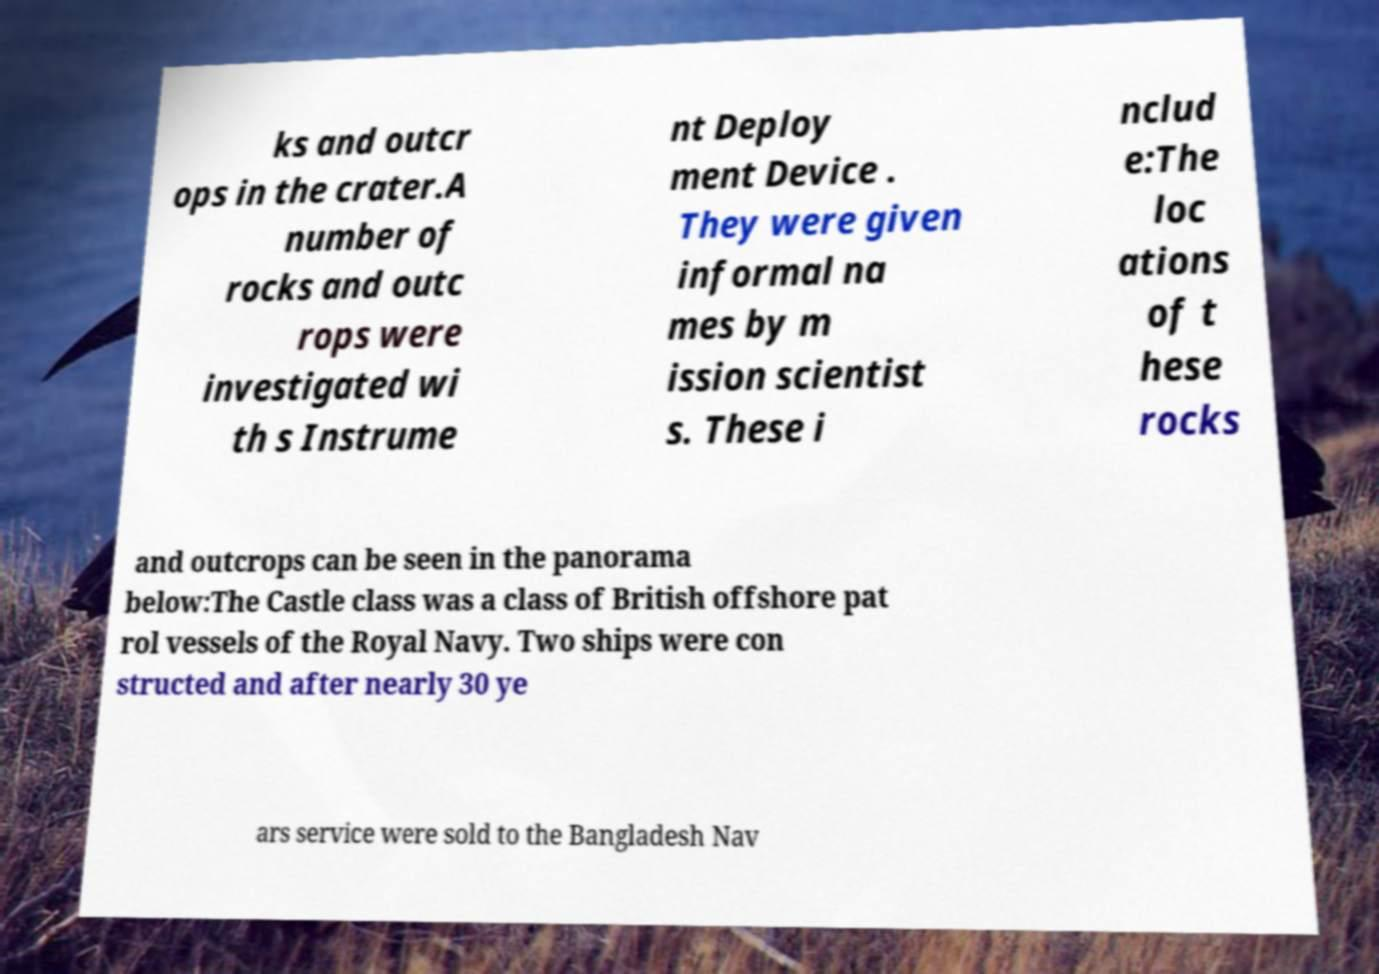Please identify and transcribe the text found in this image. ks and outcr ops in the crater.A number of rocks and outc rops were investigated wi th s Instrume nt Deploy ment Device . They were given informal na mes by m ission scientist s. These i nclud e:The loc ations of t hese rocks and outcrops can be seen in the panorama below:The Castle class was a class of British offshore pat rol vessels of the Royal Navy. Two ships were con structed and after nearly 30 ye ars service were sold to the Bangladesh Nav 